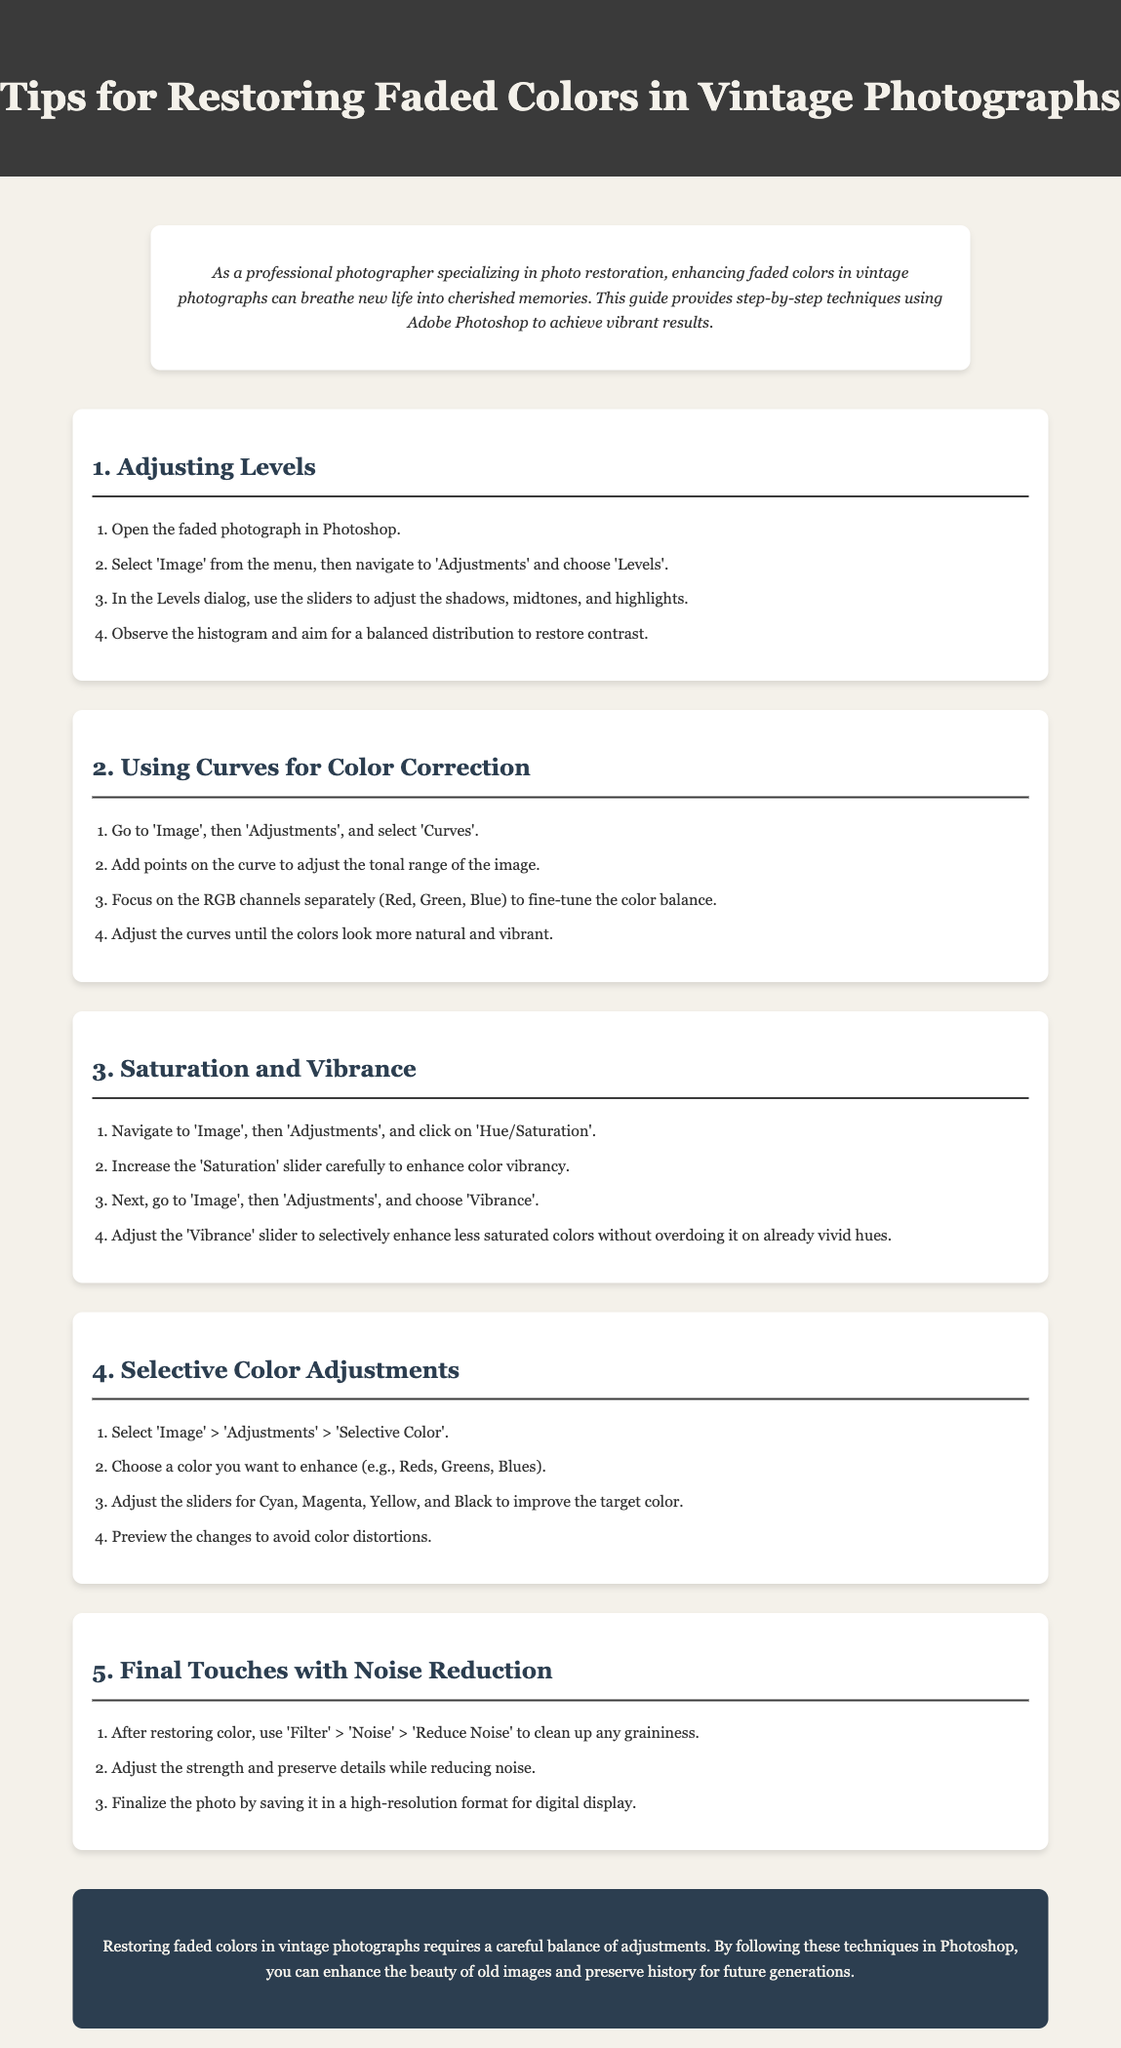What is the main purpose of the guide? The guide aims to provide techniques for enhancing faded colors in vintage photographs using Photoshop.
Answer: Enhancing faded colors How many techniques are listed in the document? The document outlines five distinct techniques for restoring colors.
Answer: Five What is the first technique mentioned? The first technique is adjusting the image's levels to restore contrast.
Answer: Adjusting Levels Which menu path is used to access the Curves adjustment? The Curves adjustment can be accessed through 'Image', then 'Adjustments', and selecting 'Curves'.
Answer: Image > Adjustments > Curves Which adjustment slider should be used carefully to enhance color vibrancy? The Saturation slider is the one that should be adjusted carefully to enhance vibrancy.
Answer: Saturation slider What is the last step suggested after restoring colors? The final step includes using noise reduction to clean any graininess from the photo.
Answer: Reduce Noise What color selection is the focus of the Selective Color Adjustments technique? The focus is on enhancing specific colors like Reds, Greens, or Blues through adjustments.
Answer: Reds, Greens, Blues Which filter is recommended for final touches on noise? The recommended filter for reducing noise is 'Reduce Noise' under the 'Noise' category.
Answer: Reduce Noise 